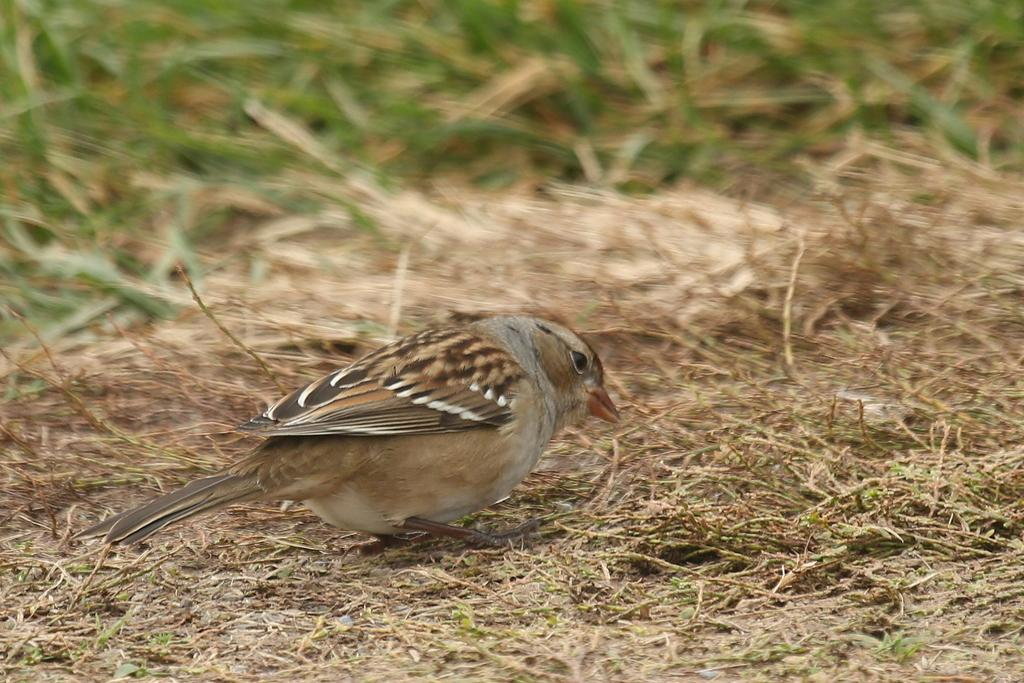What type of bird is in the image? There is a sparrow in the image. What is the ground covered with in the image? There is grass on the ground in the image. What type of trousers is the sparrow wearing in the image? Sparrows do not wear trousers, as they are birds and do not have the ability to wear clothing. 